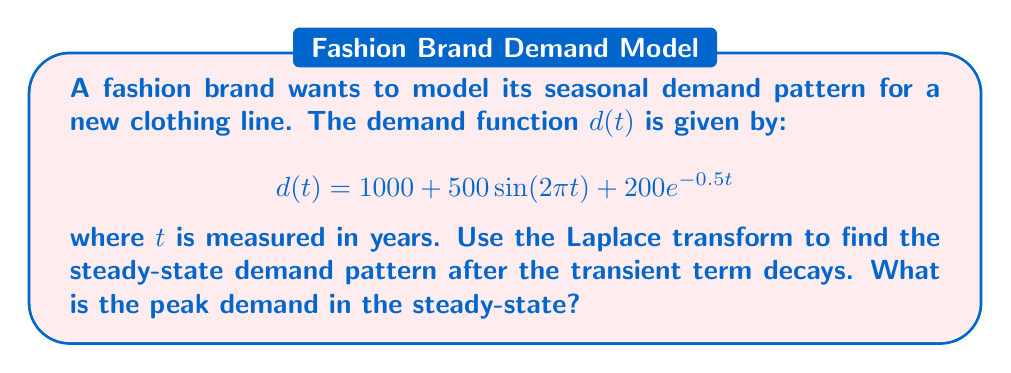Show me your answer to this math problem. To solve this problem, we'll follow these steps:

1) First, let's recall the Laplace transform of the given functions:
   - For a constant $a$: $\mathcal{L}\{a\} = \frac{a}{s}$
   - For $\sin(\omega t)$: $\mathcal{L}\{\sin(\omega t)\} = \frac{\omega}{s^2 + \omega^2}$
   - For $e^{-at}$: $\mathcal{L}\{e^{-at}\} = \frac{1}{s+a}$

2) Now, let's take the Laplace transform of $d(t)$:

   $$\mathcal{L}\{d(t)\} = \mathcal{L}\{1000 + 500\sin(2\pi t) + 200e^{-0.5t}\}$$

   $$= \frac{1000}{s} + \frac{500 \cdot 2\pi}{s^2 + (2\pi)^2} + \frac{200}{s+0.5}$$

3) The steady-state response is found by considering the limit as $t \to \infty$, which corresponds to $s \to 0$ in the s-domain. The term $\frac{200}{s+0.5}$ will decay to zero as $t \to \infty$, so we can ignore it for the steady-state analysis.

4) Taking the inverse Laplace transform of the remaining terms:

   $$d_{ss}(t) = 1000 + 500\sin(2\pi t)$$

5) This is the steady-state demand pattern. To find the peak demand, we need to find the maximum value of this function.

6) The maximum value will occur when $\sin(2\pi t) = 1$, which gives:

   $$d_{max} = 1000 + 500 = 1500$$

Therefore, the peak demand in the steady-state is 1500 units.
Answer: The peak demand in the steady-state is 1500 units. 